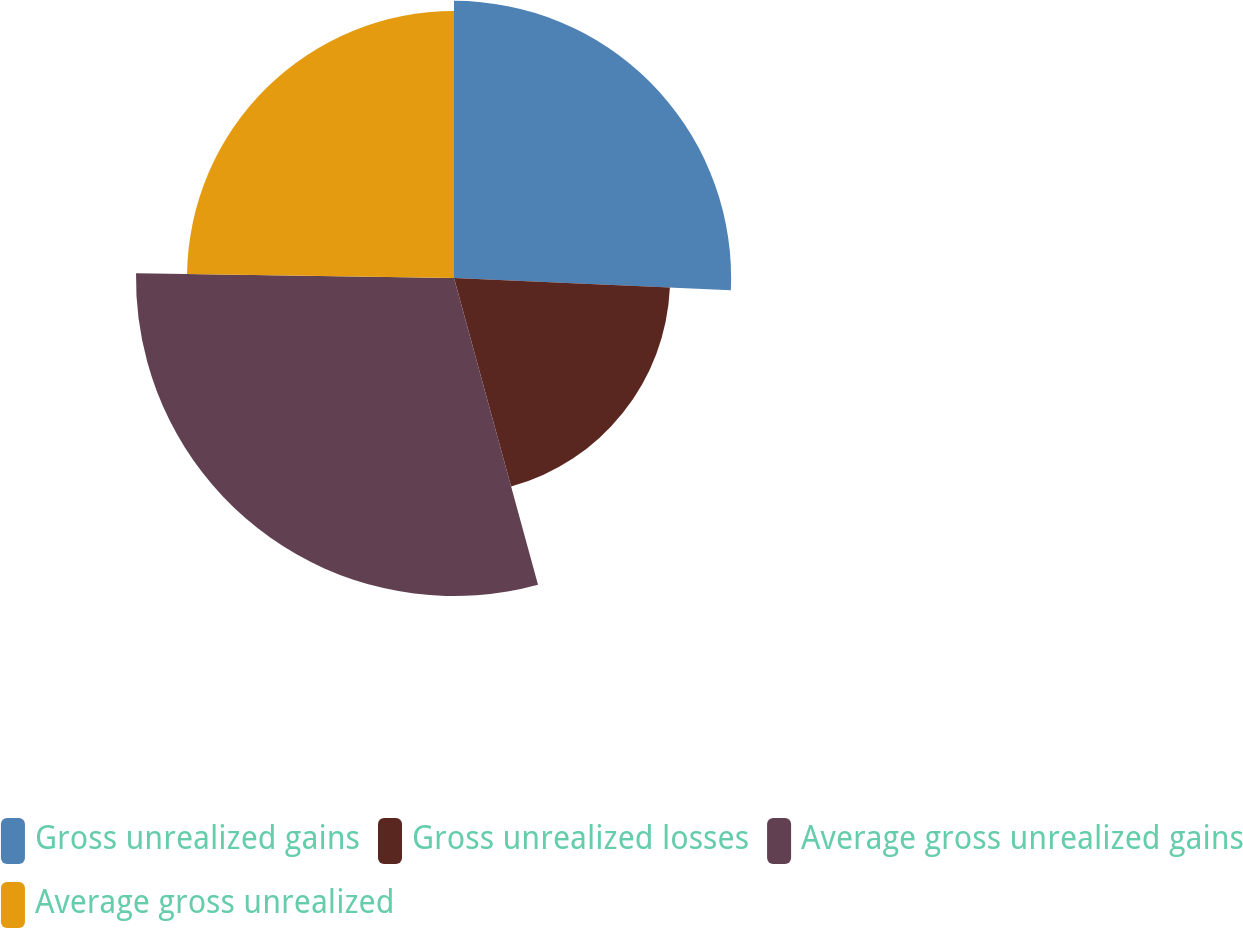Convert chart to OTSL. <chart><loc_0><loc_0><loc_500><loc_500><pie_chart><fcel>Gross unrealized gains<fcel>Gross unrealized losses<fcel>Average gross unrealized gains<fcel>Average gross unrealized<nl><fcel>25.7%<fcel>20.04%<fcel>29.49%<fcel>24.76%<nl></chart> 